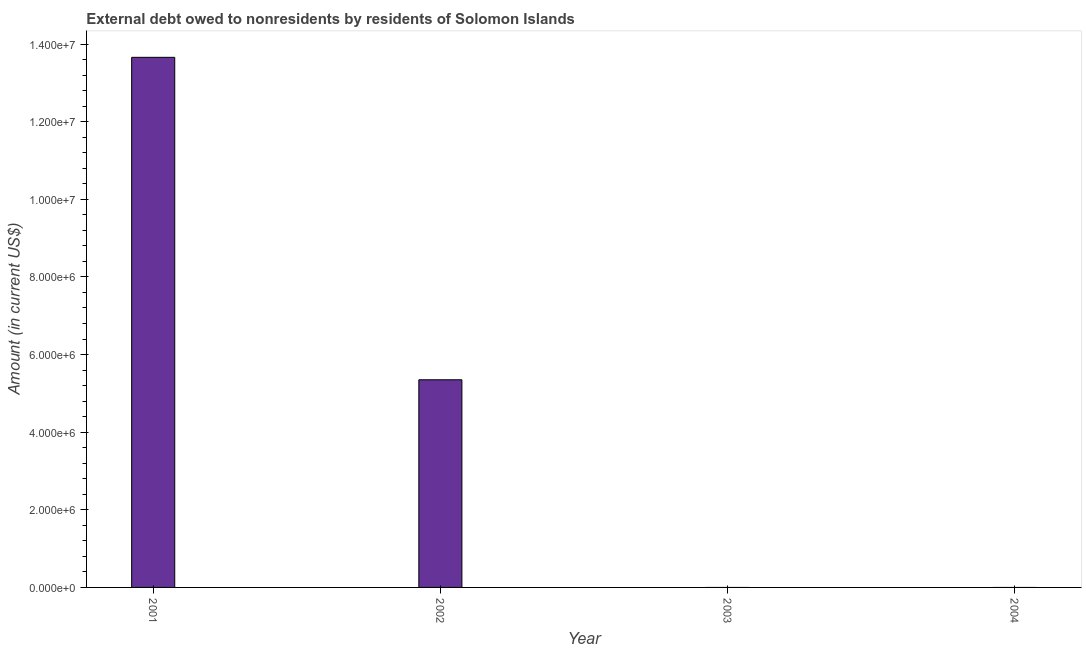What is the title of the graph?
Ensure brevity in your answer.  External debt owed to nonresidents by residents of Solomon Islands. What is the label or title of the X-axis?
Your answer should be very brief. Year. What is the label or title of the Y-axis?
Ensure brevity in your answer.  Amount (in current US$). Across all years, what is the maximum debt?
Your answer should be compact. 1.37e+07. Across all years, what is the minimum debt?
Give a very brief answer. 0. What is the sum of the debt?
Your response must be concise. 1.90e+07. What is the difference between the debt in 2001 and 2002?
Make the answer very short. 8.31e+06. What is the average debt per year?
Your answer should be very brief. 4.75e+06. What is the median debt?
Keep it short and to the point. 2.68e+06. Is the debt in 2001 less than that in 2002?
Provide a succinct answer. No. What is the difference between the highest and the lowest debt?
Your answer should be very brief. 1.37e+07. Are all the bars in the graph horizontal?
Give a very brief answer. No. Are the values on the major ticks of Y-axis written in scientific E-notation?
Your answer should be very brief. Yes. What is the Amount (in current US$) in 2001?
Keep it short and to the point. 1.37e+07. What is the Amount (in current US$) of 2002?
Provide a short and direct response. 5.35e+06. What is the Amount (in current US$) of 2003?
Provide a short and direct response. 0. What is the difference between the Amount (in current US$) in 2001 and 2002?
Ensure brevity in your answer.  8.31e+06. What is the ratio of the Amount (in current US$) in 2001 to that in 2002?
Your answer should be very brief. 2.55. 